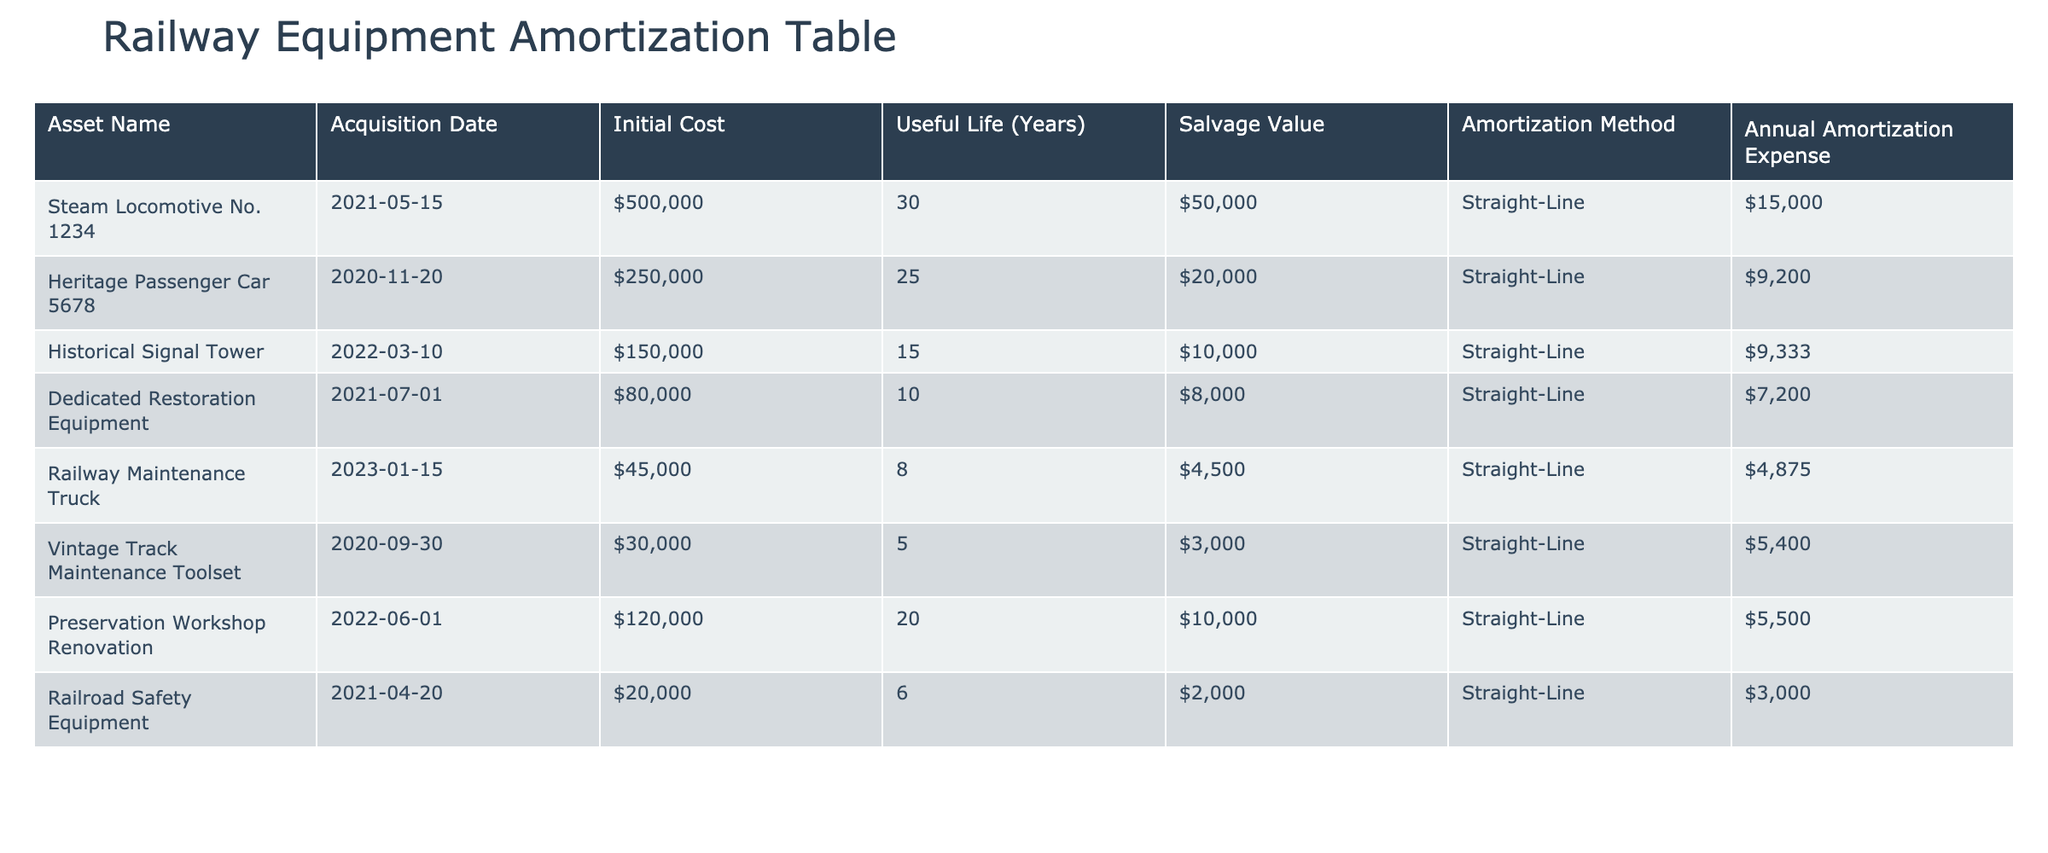What is the initial cost of the Heritage Passenger Car 5678? The table lists the initial cost for each asset, and by locating the row corresponding to Heritage Passenger Car 5678, the value is $250,000.
Answer: $250,000 What is the total annual amortization expense for all the assets? To find the total, sum the annual amortization expenses: 15,000 + 9,200 + 9,333 + 7,200 + 4,875 + 5,400 + 5,500 + 3,000 = 54,508.
Answer: $54,508 Is the salvage value of the Steam Locomotive No. 1234 greater than the salvage value of the Historical Signal Tower? The table shows the salvage value for Steam Locomotive No. 1234 is $50,000, and for Historical Signal Tower, it is $10,000. Since 50,000 > 10,000, the statement is true.
Answer: Yes What is the average useful life of all the assets listed? To compute the average useful life, add all useful lives (30 + 25 + 15 + 10 + 8 + 5 + 20 + 6) = 119, then divide by the number of assets (8): 119 / 8 = 14.875.
Answer: 14.875 years Which equipment has the longest useful life? By reviewing the useful life of each asset, which is listed in the table, Steam Locomotive No. 1234 has the longest useful life at 30 years.
Answer: Steam Locomotive No. 1234 What is the difference in annual amortization expense between the Heritage Passenger Car 5678 and the Vintage Track Maintenance Toolset? The annual amortization expense for Heritage Passenger Car 5678 is 9,200 and for Vintage Track Maintenance Toolset is 5,400. The difference is calculated as 9,200 - 5,400 = 3,800.
Answer: $3,800 Is the initial cost of the Railway Maintenance Truck less than $50,000? The initial cost of the Railway Maintenance Truck is $45,000, which is indeed less than $50,000, making the statement true.
Answer: Yes What is the total salvage value of the Dedicated Restoration Equipment and the Preservation Workshop Renovation? The salvage value of Dedicated Restoration Equipment is $8,000 and for Preservation Workshop Renovation, it is $10,000. The total is 8,000 + 10,000 = 18,000.
Answer: $18,000 